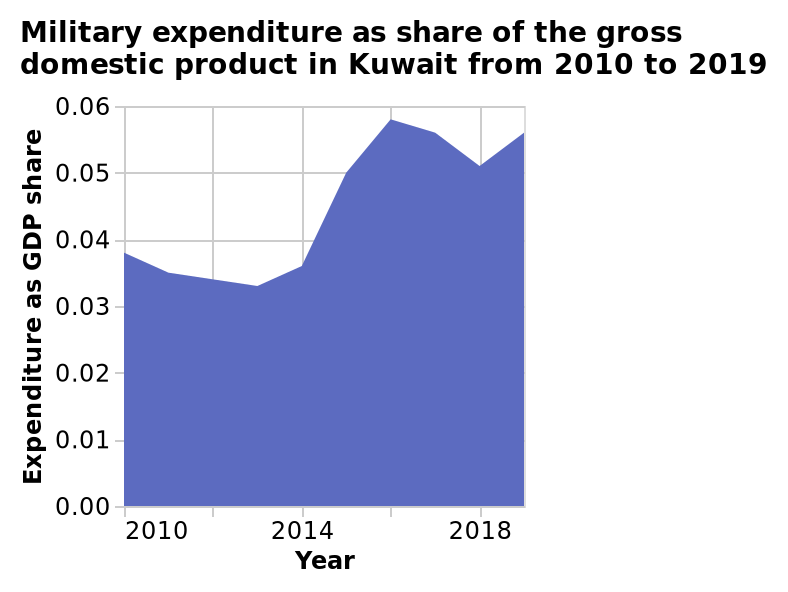<image>
What can be said about the expenditure in 2014? The information does not provide any specific details about the expenditure in 2014. 